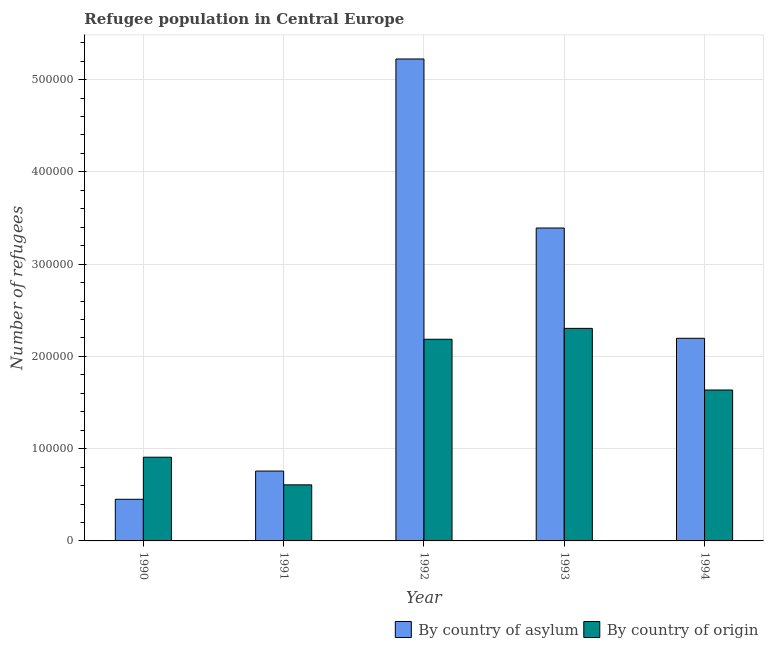Are the number of bars per tick equal to the number of legend labels?
Your answer should be compact. Yes. Are the number of bars on each tick of the X-axis equal?
Offer a very short reply. Yes. How many bars are there on the 3rd tick from the left?
Your answer should be very brief. 2. What is the label of the 3rd group of bars from the left?
Make the answer very short. 1992. In how many cases, is the number of bars for a given year not equal to the number of legend labels?
Keep it short and to the point. 0. What is the number of refugees by country of origin in 1992?
Provide a succinct answer. 2.19e+05. Across all years, what is the maximum number of refugees by country of origin?
Give a very brief answer. 2.30e+05. Across all years, what is the minimum number of refugees by country of asylum?
Give a very brief answer. 4.51e+04. In which year was the number of refugees by country of origin minimum?
Provide a succinct answer. 1991. What is the total number of refugees by country of asylum in the graph?
Keep it short and to the point. 1.20e+06. What is the difference between the number of refugees by country of asylum in 1991 and that in 1994?
Provide a succinct answer. -1.44e+05. What is the difference between the number of refugees by country of origin in 1990 and the number of refugees by country of asylum in 1993?
Your response must be concise. -1.40e+05. What is the average number of refugees by country of origin per year?
Your answer should be compact. 1.53e+05. In the year 1992, what is the difference between the number of refugees by country of asylum and number of refugees by country of origin?
Your response must be concise. 0. In how many years, is the number of refugees by country of origin greater than 220000?
Give a very brief answer. 1. What is the ratio of the number of refugees by country of asylum in 1992 to that in 1993?
Your response must be concise. 1.54. Is the number of refugees by country of asylum in 1990 less than that in 1994?
Offer a very short reply. Yes. Is the difference between the number of refugees by country of asylum in 1990 and 1994 greater than the difference between the number of refugees by country of origin in 1990 and 1994?
Provide a succinct answer. No. What is the difference between the highest and the second highest number of refugees by country of origin?
Offer a terse response. 1.18e+04. What is the difference between the highest and the lowest number of refugees by country of asylum?
Your answer should be compact. 4.77e+05. Is the sum of the number of refugees by country of origin in 1990 and 1991 greater than the maximum number of refugees by country of asylum across all years?
Ensure brevity in your answer.  No. What does the 2nd bar from the left in 1994 represents?
Offer a very short reply. By country of origin. What does the 2nd bar from the right in 1993 represents?
Give a very brief answer. By country of asylum. Are all the bars in the graph horizontal?
Offer a terse response. No. What is the difference between two consecutive major ticks on the Y-axis?
Provide a succinct answer. 1.00e+05. Does the graph contain any zero values?
Your response must be concise. No. Does the graph contain grids?
Make the answer very short. Yes. How are the legend labels stacked?
Give a very brief answer. Horizontal. What is the title of the graph?
Your response must be concise. Refugee population in Central Europe. Does "% of gross capital formation" appear as one of the legend labels in the graph?
Provide a short and direct response. No. What is the label or title of the X-axis?
Make the answer very short. Year. What is the label or title of the Y-axis?
Offer a very short reply. Number of refugees. What is the Number of refugees of By country of asylum in 1990?
Offer a very short reply. 4.51e+04. What is the Number of refugees in By country of origin in 1990?
Your response must be concise. 9.07e+04. What is the Number of refugees in By country of asylum in 1991?
Offer a terse response. 7.57e+04. What is the Number of refugees in By country of origin in 1991?
Provide a short and direct response. 6.08e+04. What is the Number of refugees in By country of asylum in 1992?
Your response must be concise. 5.22e+05. What is the Number of refugees of By country of origin in 1992?
Ensure brevity in your answer.  2.19e+05. What is the Number of refugees in By country of asylum in 1993?
Ensure brevity in your answer.  3.39e+05. What is the Number of refugees of By country of origin in 1993?
Make the answer very short. 2.30e+05. What is the Number of refugees of By country of asylum in 1994?
Offer a terse response. 2.20e+05. What is the Number of refugees in By country of origin in 1994?
Your answer should be compact. 1.64e+05. Across all years, what is the maximum Number of refugees of By country of asylum?
Ensure brevity in your answer.  5.22e+05. Across all years, what is the maximum Number of refugees of By country of origin?
Your answer should be compact. 2.30e+05. Across all years, what is the minimum Number of refugees in By country of asylum?
Ensure brevity in your answer.  4.51e+04. Across all years, what is the minimum Number of refugees in By country of origin?
Give a very brief answer. 6.08e+04. What is the total Number of refugees of By country of asylum in the graph?
Give a very brief answer. 1.20e+06. What is the total Number of refugees in By country of origin in the graph?
Keep it short and to the point. 7.64e+05. What is the difference between the Number of refugees in By country of asylum in 1990 and that in 1991?
Give a very brief answer. -3.06e+04. What is the difference between the Number of refugees in By country of origin in 1990 and that in 1991?
Your answer should be very brief. 2.99e+04. What is the difference between the Number of refugees of By country of asylum in 1990 and that in 1992?
Your response must be concise. -4.77e+05. What is the difference between the Number of refugees in By country of origin in 1990 and that in 1992?
Offer a terse response. -1.28e+05. What is the difference between the Number of refugees in By country of asylum in 1990 and that in 1993?
Make the answer very short. -2.94e+05. What is the difference between the Number of refugees in By country of origin in 1990 and that in 1993?
Keep it short and to the point. -1.40e+05. What is the difference between the Number of refugees of By country of asylum in 1990 and that in 1994?
Make the answer very short. -1.75e+05. What is the difference between the Number of refugees in By country of origin in 1990 and that in 1994?
Offer a terse response. -7.28e+04. What is the difference between the Number of refugees of By country of asylum in 1991 and that in 1992?
Your answer should be very brief. -4.47e+05. What is the difference between the Number of refugees of By country of origin in 1991 and that in 1992?
Provide a short and direct response. -1.58e+05. What is the difference between the Number of refugees of By country of asylum in 1991 and that in 1993?
Your answer should be compact. -2.63e+05. What is the difference between the Number of refugees of By country of origin in 1991 and that in 1993?
Your answer should be very brief. -1.70e+05. What is the difference between the Number of refugees in By country of asylum in 1991 and that in 1994?
Make the answer very short. -1.44e+05. What is the difference between the Number of refugees of By country of origin in 1991 and that in 1994?
Give a very brief answer. -1.03e+05. What is the difference between the Number of refugees in By country of asylum in 1992 and that in 1993?
Give a very brief answer. 1.83e+05. What is the difference between the Number of refugees in By country of origin in 1992 and that in 1993?
Keep it short and to the point. -1.18e+04. What is the difference between the Number of refugees in By country of asylum in 1992 and that in 1994?
Provide a short and direct response. 3.03e+05. What is the difference between the Number of refugees of By country of origin in 1992 and that in 1994?
Make the answer very short. 5.50e+04. What is the difference between the Number of refugees of By country of asylum in 1993 and that in 1994?
Ensure brevity in your answer.  1.20e+05. What is the difference between the Number of refugees in By country of origin in 1993 and that in 1994?
Give a very brief answer. 6.68e+04. What is the difference between the Number of refugees in By country of asylum in 1990 and the Number of refugees in By country of origin in 1991?
Provide a short and direct response. -1.57e+04. What is the difference between the Number of refugees of By country of asylum in 1990 and the Number of refugees of By country of origin in 1992?
Your answer should be compact. -1.73e+05. What is the difference between the Number of refugees in By country of asylum in 1990 and the Number of refugees in By country of origin in 1993?
Make the answer very short. -1.85e+05. What is the difference between the Number of refugees in By country of asylum in 1990 and the Number of refugees in By country of origin in 1994?
Provide a succinct answer. -1.18e+05. What is the difference between the Number of refugees of By country of asylum in 1991 and the Number of refugees of By country of origin in 1992?
Your response must be concise. -1.43e+05. What is the difference between the Number of refugees of By country of asylum in 1991 and the Number of refugees of By country of origin in 1993?
Your answer should be compact. -1.55e+05. What is the difference between the Number of refugees in By country of asylum in 1991 and the Number of refugees in By country of origin in 1994?
Offer a very short reply. -8.78e+04. What is the difference between the Number of refugees in By country of asylum in 1992 and the Number of refugees in By country of origin in 1993?
Offer a very short reply. 2.92e+05. What is the difference between the Number of refugees in By country of asylum in 1992 and the Number of refugees in By country of origin in 1994?
Offer a terse response. 3.59e+05. What is the difference between the Number of refugees of By country of asylum in 1993 and the Number of refugees of By country of origin in 1994?
Give a very brief answer. 1.76e+05. What is the average Number of refugees in By country of asylum per year?
Give a very brief answer. 2.40e+05. What is the average Number of refugees of By country of origin per year?
Provide a short and direct response. 1.53e+05. In the year 1990, what is the difference between the Number of refugees in By country of asylum and Number of refugees in By country of origin?
Offer a very short reply. -4.56e+04. In the year 1991, what is the difference between the Number of refugees of By country of asylum and Number of refugees of By country of origin?
Keep it short and to the point. 1.49e+04. In the year 1992, what is the difference between the Number of refugees of By country of asylum and Number of refugees of By country of origin?
Keep it short and to the point. 3.04e+05. In the year 1993, what is the difference between the Number of refugees in By country of asylum and Number of refugees in By country of origin?
Your answer should be compact. 1.09e+05. In the year 1994, what is the difference between the Number of refugees of By country of asylum and Number of refugees of By country of origin?
Your answer should be very brief. 5.61e+04. What is the ratio of the Number of refugees in By country of asylum in 1990 to that in 1991?
Provide a succinct answer. 0.6. What is the ratio of the Number of refugees in By country of origin in 1990 to that in 1991?
Give a very brief answer. 1.49. What is the ratio of the Number of refugees in By country of asylum in 1990 to that in 1992?
Give a very brief answer. 0.09. What is the ratio of the Number of refugees of By country of origin in 1990 to that in 1992?
Provide a short and direct response. 0.42. What is the ratio of the Number of refugees of By country of asylum in 1990 to that in 1993?
Provide a succinct answer. 0.13. What is the ratio of the Number of refugees of By country of origin in 1990 to that in 1993?
Your response must be concise. 0.39. What is the ratio of the Number of refugees of By country of asylum in 1990 to that in 1994?
Provide a succinct answer. 0.21. What is the ratio of the Number of refugees of By country of origin in 1990 to that in 1994?
Provide a succinct answer. 0.55. What is the ratio of the Number of refugees in By country of asylum in 1991 to that in 1992?
Keep it short and to the point. 0.14. What is the ratio of the Number of refugees in By country of origin in 1991 to that in 1992?
Your answer should be very brief. 0.28. What is the ratio of the Number of refugees in By country of asylum in 1991 to that in 1993?
Your answer should be compact. 0.22. What is the ratio of the Number of refugees in By country of origin in 1991 to that in 1993?
Provide a short and direct response. 0.26. What is the ratio of the Number of refugees in By country of asylum in 1991 to that in 1994?
Make the answer very short. 0.34. What is the ratio of the Number of refugees in By country of origin in 1991 to that in 1994?
Keep it short and to the point. 0.37. What is the ratio of the Number of refugees of By country of asylum in 1992 to that in 1993?
Your answer should be very brief. 1.54. What is the ratio of the Number of refugees in By country of origin in 1992 to that in 1993?
Keep it short and to the point. 0.95. What is the ratio of the Number of refugees of By country of asylum in 1992 to that in 1994?
Keep it short and to the point. 2.38. What is the ratio of the Number of refugees of By country of origin in 1992 to that in 1994?
Ensure brevity in your answer.  1.34. What is the ratio of the Number of refugees of By country of asylum in 1993 to that in 1994?
Ensure brevity in your answer.  1.54. What is the ratio of the Number of refugees of By country of origin in 1993 to that in 1994?
Your answer should be very brief. 1.41. What is the difference between the highest and the second highest Number of refugees in By country of asylum?
Offer a terse response. 1.83e+05. What is the difference between the highest and the second highest Number of refugees in By country of origin?
Give a very brief answer. 1.18e+04. What is the difference between the highest and the lowest Number of refugees of By country of asylum?
Your answer should be very brief. 4.77e+05. What is the difference between the highest and the lowest Number of refugees of By country of origin?
Make the answer very short. 1.70e+05. 